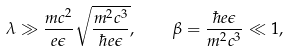<formula> <loc_0><loc_0><loc_500><loc_500>\lambda \gg \frac { m c ^ { 2 } } { e \epsilon } \sqrt { \frac { m ^ { 2 } c ^ { 3 } } { \hbar { e } \epsilon } } , \quad \beta = \frac { \hbar { e } \epsilon } { m ^ { 2 } c ^ { 3 } } \ll 1 ,</formula> 